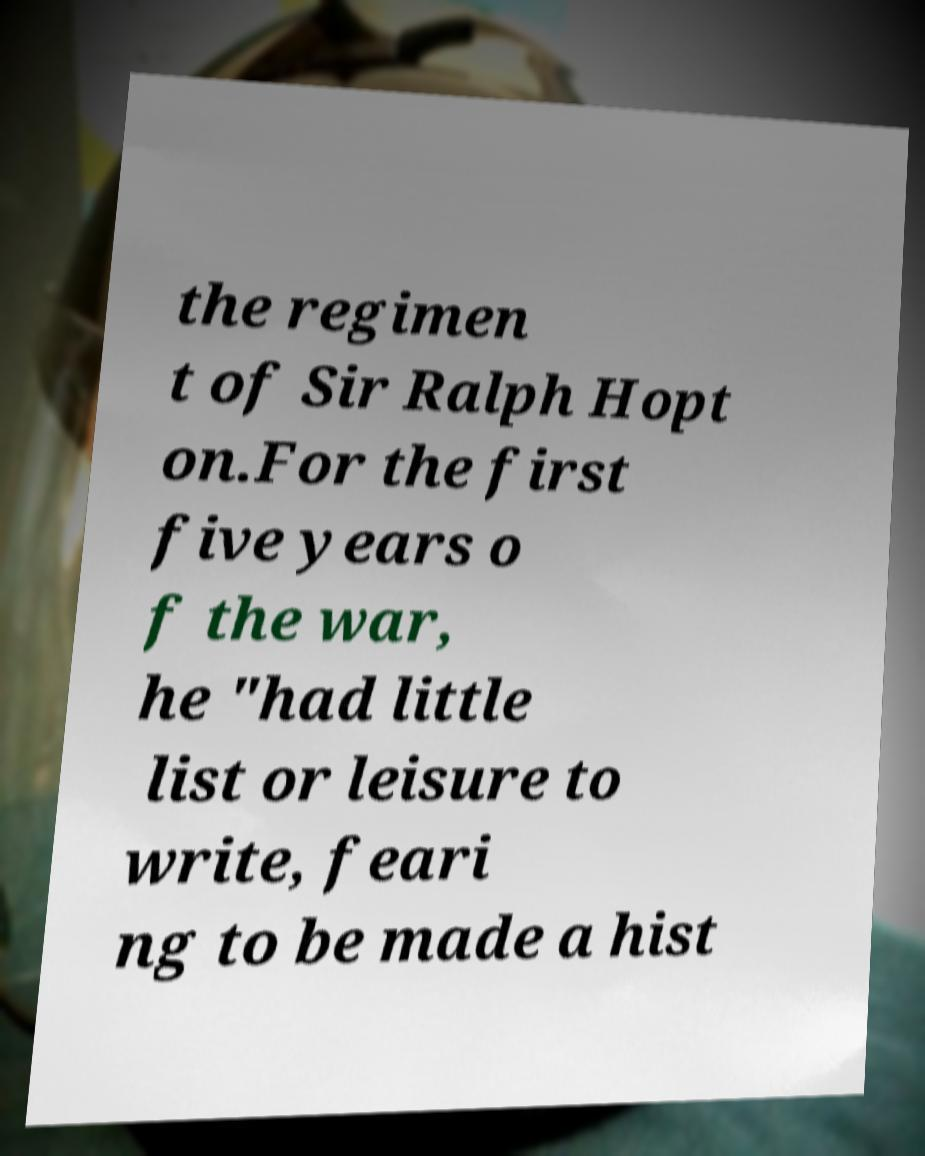Could you assist in decoding the text presented in this image and type it out clearly? the regimen t of Sir Ralph Hopt on.For the first five years o f the war, he "had little list or leisure to write, feari ng to be made a hist 